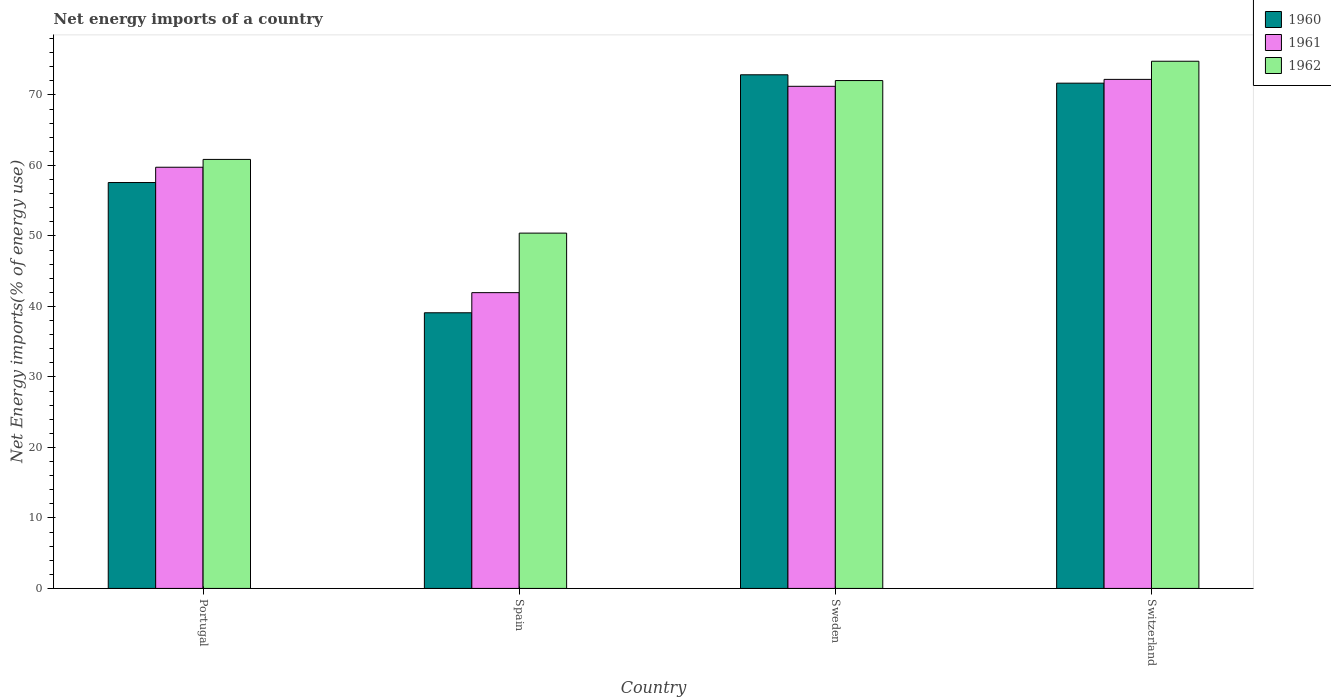Are the number of bars per tick equal to the number of legend labels?
Keep it short and to the point. Yes. Are the number of bars on each tick of the X-axis equal?
Offer a terse response. Yes. What is the net energy imports in 1961 in Spain?
Offer a very short reply. 41.95. Across all countries, what is the maximum net energy imports in 1960?
Your response must be concise. 72.86. Across all countries, what is the minimum net energy imports in 1962?
Provide a succinct answer. 50.4. In which country was the net energy imports in 1961 maximum?
Offer a terse response. Switzerland. In which country was the net energy imports in 1960 minimum?
Your answer should be very brief. Spain. What is the total net energy imports in 1960 in the graph?
Give a very brief answer. 241.2. What is the difference between the net energy imports in 1962 in Spain and that in Switzerland?
Your answer should be very brief. -24.38. What is the difference between the net energy imports in 1962 in Spain and the net energy imports in 1961 in Sweden?
Keep it short and to the point. -20.83. What is the average net energy imports in 1961 per country?
Make the answer very short. 61.28. What is the difference between the net energy imports of/in 1960 and net energy imports of/in 1961 in Sweden?
Make the answer very short. 1.63. What is the ratio of the net energy imports in 1960 in Spain to that in Switzerland?
Keep it short and to the point. 0.55. Is the net energy imports in 1961 in Portugal less than that in Switzerland?
Provide a succinct answer. Yes. What is the difference between the highest and the second highest net energy imports in 1961?
Your answer should be very brief. 12.46. What is the difference between the highest and the lowest net energy imports in 1961?
Your answer should be very brief. 30.25. Are all the bars in the graph horizontal?
Provide a succinct answer. No. How many countries are there in the graph?
Ensure brevity in your answer.  4. What is the difference between two consecutive major ticks on the Y-axis?
Your response must be concise. 10. Are the values on the major ticks of Y-axis written in scientific E-notation?
Your response must be concise. No. Where does the legend appear in the graph?
Make the answer very short. Top right. What is the title of the graph?
Offer a terse response. Net energy imports of a country. Does "1994" appear as one of the legend labels in the graph?
Ensure brevity in your answer.  No. What is the label or title of the Y-axis?
Offer a terse response. Net Energy imports(% of energy use). What is the Net Energy imports(% of energy use) of 1960 in Portugal?
Your answer should be very brief. 57.57. What is the Net Energy imports(% of energy use) of 1961 in Portugal?
Your answer should be compact. 59.74. What is the Net Energy imports(% of energy use) in 1962 in Portugal?
Your answer should be very brief. 60.85. What is the Net Energy imports(% of energy use) in 1960 in Spain?
Make the answer very short. 39.1. What is the Net Energy imports(% of energy use) of 1961 in Spain?
Ensure brevity in your answer.  41.95. What is the Net Energy imports(% of energy use) of 1962 in Spain?
Provide a short and direct response. 50.4. What is the Net Energy imports(% of energy use) of 1960 in Sweden?
Give a very brief answer. 72.86. What is the Net Energy imports(% of energy use) of 1961 in Sweden?
Keep it short and to the point. 71.22. What is the Net Energy imports(% of energy use) in 1962 in Sweden?
Give a very brief answer. 72.04. What is the Net Energy imports(% of energy use) in 1960 in Switzerland?
Your response must be concise. 71.67. What is the Net Energy imports(% of energy use) in 1961 in Switzerland?
Provide a short and direct response. 72.21. What is the Net Energy imports(% of energy use) in 1962 in Switzerland?
Give a very brief answer. 74.78. Across all countries, what is the maximum Net Energy imports(% of energy use) in 1960?
Give a very brief answer. 72.86. Across all countries, what is the maximum Net Energy imports(% of energy use) in 1961?
Make the answer very short. 72.21. Across all countries, what is the maximum Net Energy imports(% of energy use) in 1962?
Your response must be concise. 74.78. Across all countries, what is the minimum Net Energy imports(% of energy use) in 1960?
Your response must be concise. 39.1. Across all countries, what is the minimum Net Energy imports(% of energy use) of 1961?
Ensure brevity in your answer.  41.95. Across all countries, what is the minimum Net Energy imports(% of energy use) in 1962?
Keep it short and to the point. 50.4. What is the total Net Energy imports(% of energy use) of 1960 in the graph?
Keep it short and to the point. 241.2. What is the total Net Energy imports(% of energy use) in 1961 in the graph?
Your response must be concise. 245.13. What is the total Net Energy imports(% of energy use) in 1962 in the graph?
Provide a short and direct response. 258.07. What is the difference between the Net Energy imports(% of energy use) of 1960 in Portugal and that in Spain?
Provide a short and direct response. 18.47. What is the difference between the Net Energy imports(% of energy use) in 1961 in Portugal and that in Spain?
Provide a succinct answer. 17.79. What is the difference between the Net Energy imports(% of energy use) in 1962 in Portugal and that in Spain?
Provide a short and direct response. 10.46. What is the difference between the Net Energy imports(% of energy use) in 1960 in Portugal and that in Sweden?
Provide a succinct answer. -15.28. What is the difference between the Net Energy imports(% of energy use) of 1961 in Portugal and that in Sweden?
Keep it short and to the point. -11.48. What is the difference between the Net Energy imports(% of energy use) in 1962 in Portugal and that in Sweden?
Your answer should be compact. -11.18. What is the difference between the Net Energy imports(% of energy use) in 1960 in Portugal and that in Switzerland?
Provide a succinct answer. -14.09. What is the difference between the Net Energy imports(% of energy use) of 1961 in Portugal and that in Switzerland?
Your answer should be compact. -12.46. What is the difference between the Net Energy imports(% of energy use) in 1962 in Portugal and that in Switzerland?
Your answer should be very brief. -13.93. What is the difference between the Net Energy imports(% of energy use) in 1960 in Spain and that in Sweden?
Offer a very short reply. -33.76. What is the difference between the Net Energy imports(% of energy use) in 1961 in Spain and that in Sweden?
Provide a succinct answer. -29.27. What is the difference between the Net Energy imports(% of energy use) of 1962 in Spain and that in Sweden?
Make the answer very short. -21.64. What is the difference between the Net Energy imports(% of energy use) of 1960 in Spain and that in Switzerland?
Ensure brevity in your answer.  -32.57. What is the difference between the Net Energy imports(% of energy use) in 1961 in Spain and that in Switzerland?
Make the answer very short. -30.25. What is the difference between the Net Energy imports(% of energy use) of 1962 in Spain and that in Switzerland?
Ensure brevity in your answer.  -24.38. What is the difference between the Net Energy imports(% of energy use) of 1960 in Sweden and that in Switzerland?
Your answer should be compact. 1.19. What is the difference between the Net Energy imports(% of energy use) of 1961 in Sweden and that in Switzerland?
Provide a succinct answer. -0.98. What is the difference between the Net Energy imports(% of energy use) of 1962 in Sweden and that in Switzerland?
Make the answer very short. -2.74. What is the difference between the Net Energy imports(% of energy use) of 1960 in Portugal and the Net Energy imports(% of energy use) of 1961 in Spain?
Your answer should be very brief. 15.62. What is the difference between the Net Energy imports(% of energy use) in 1960 in Portugal and the Net Energy imports(% of energy use) in 1962 in Spain?
Your response must be concise. 7.18. What is the difference between the Net Energy imports(% of energy use) in 1961 in Portugal and the Net Energy imports(% of energy use) in 1962 in Spain?
Give a very brief answer. 9.34. What is the difference between the Net Energy imports(% of energy use) in 1960 in Portugal and the Net Energy imports(% of energy use) in 1961 in Sweden?
Provide a short and direct response. -13.65. What is the difference between the Net Energy imports(% of energy use) in 1960 in Portugal and the Net Energy imports(% of energy use) in 1962 in Sweden?
Make the answer very short. -14.46. What is the difference between the Net Energy imports(% of energy use) of 1961 in Portugal and the Net Energy imports(% of energy use) of 1962 in Sweden?
Your response must be concise. -12.3. What is the difference between the Net Energy imports(% of energy use) in 1960 in Portugal and the Net Energy imports(% of energy use) in 1961 in Switzerland?
Your answer should be compact. -14.63. What is the difference between the Net Energy imports(% of energy use) of 1960 in Portugal and the Net Energy imports(% of energy use) of 1962 in Switzerland?
Your answer should be very brief. -17.21. What is the difference between the Net Energy imports(% of energy use) in 1961 in Portugal and the Net Energy imports(% of energy use) in 1962 in Switzerland?
Your answer should be very brief. -15.04. What is the difference between the Net Energy imports(% of energy use) of 1960 in Spain and the Net Energy imports(% of energy use) of 1961 in Sweden?
Your response must be concise. -32.12. What is the difference between the Net Energy imports(% of energy use) in 1960 in Spain and the Net Energy imports(% of energy use) in 1962 in Sweden?
Keep it short and to the point. -32.94. What is the difference between the Net Energy imports(% of energy use) of 1961 in Spain and the Net Energy imports(% of energy use) of 1962 in Sweden?
Make the answer very short. -30.08. What is the difference between the Net Energy imports(% of energy use) in 1960 in Spain and the Net Energy imports(% of energy use) in 1961 in Switzerland?
Your answer should be compact. -33.11. What is the difference between the Net Energy imports(% of energy use) in 1960 in Spain and the Net Energy imports(% of energy use) in 1962 in Switzerland?
Provide a succinct answer. -35.68. What is the difference between the Net Energy imports(% of energy use) in 1961 in Spain and the Net Energy imports(% of energy use) in 1962 in Switzerland?
Your answer should be very brief. -32.82. What is the difference between the Net Energy imports(% of energy use) in 1960 in Sweden and the Net Energy imports(% of energy use) in 1961 in Switzerland?
Your answer should be compact. 0.65. What is the difference between the Net Energy imports(% of energy use) in 1960 in Sweden and the Net Energy imports(% of energy use) in 1962 in Switzerland?
Make the answer very short. -1.92. What is the difference between the Net Energy imports(% of energy use) in 1961 in Sweden and the Net Energy imports(% of energy use) in 1962 in Switzerland?
Offer a very short reply. -3.56. What is the average Net Energy imports(% of energy use) of 1960 per country?
Ensure brevity in your answer.  60.3. What is the average Net Energy imports(% of energy use) of 1961 per country?
Make the answer very short. 61.28. What is the average Net Energy imports(% of energy use) of 1962 per country?
Ensure brevity in your answer.  64.52. What is the difference between the Net Energy imports(% of energy use) of 1960 and Net Energy imports(% of energy use) of 1961 in Portugal?
Your answer should be very brief. -2.17. What is the difference between the Net Energy imports(% of energy use) of 1960 and Net Energy imports(% of energy use) of 1962 in Portugal?
Keep it short and to the point. -3.28. What is the difference between the Net Energy imports(% of energy use) in 1961 and Net Energy imports(% of energy use) in 1962 in Portugal?
Provide a succinct answer. -1.11. What is the difference between the Net Energy imports(% of energy use) of 1960 and Net Energy imports(% of energy use) of 1961 in Spain?
Keep it short and to the point. -2.85. What is the difference between the Net Energy imports(% of energy use) in 1960 and Net Energy imports(% of energy use) in 1962 in Spain?
Your answer should be very brief. -11.3. What is the difference between the Net Energy imports(% of energy use) in 1961 and Net Energy imports(% of energy use) in 1962 in Spain?
Keep it short and to the point. -8.44. What is the difference between the Net Energy imports(% of energy use) of 1960 and Net Energy imports(% of energy use) of 1961 in Sweden?
Provide a succinct answer. 1.63. What is the difference between the Net Energy imports(% of energy use) in 1960 and Net Energy imports(% of energy use) in 1962 in Sweden?
Your answer should be compact. 0.82. What is the difference between the Net Energy imports(% of energy use) of 1961 and Net Energy imports(% of energy use) of 1962 in Sweden?
Provide a short and direct response. -0.81. What is the difference between the Net Energy imports(% of energy use) in 1960 and Net Energy imports(% of energy use) in 1961 in Switzerland?
Your response must be concise. -0.54. What is the difference between the Net Energy imports(% of energy use) in 1960 and Net Energy imports(% of energy use) in 1962 in Switzerland?
Provide a succinct answer. -3.11. What is the difference between the Net Energy imports(% of energy use) of 1961 and Net Energy imports(% of energy use) of 1962 in Switzerland?
Provide a short and direct response. -2.57. What is the ratio of the Net Energy imports(% of energy use) of 1960 in Portugal to that in Spain?
Your answer should be compact. 1.47. What is the ratio of the Net Energy imports(% of energy use) of 1961 in Portugal to that in Spain?
Your answer should be compact. 1.42. What is the ratio of the Net Energy imports(% of energy use) in 1962 in Portugal to that in Spain?
Make the answer very short. 1.21. What is the ratio of the Net Energy imports(% of energy use) of 1960 in Portugal to that in Sweden?
Give a very brief answer. 0.79. What is the ratio of the Net Energy imports(% of energy use) of 1961 in Portugal to that in Sweden?
Your answer should be very brief. 0.84. What is the ratio of the Net Energy imports(% of energy use) of 1962 in Portugal to that in Sweden?
Your answer should be compact. 0.84. What is the ratio of the Net Energy imports(% of energy use) of 1960 in Portugal to that in Switzerland?
Your answer should be very brief. 0.8. What is the ratio of the Net Energy imports(% of energy use) in 1961 in Portugal to that in Switzerland?
Offer a terse response. 0.83. What is the ratio of the Net Energy imports(% of energy use) in 1962 in Portugal to that in Switzerland?
Offer a very short reply. 0.81. What is the ratio of the Net Energy imports(% of energy use) of 1960 in Spain to that in Sweden?
Provide a short and direct response. 0.54. What is the ratio of the Net Energy imports(% of energy use) of 1961 in Spain to that in Sweden?
Provide a succinct answer. 0.59. What is the ratio of the Net Energy imports(% of energy use) in 1962 in Spain to that in Sweden?
Offer a very short reply. 0.7. What is the ratio of the Net Energy imports(% of energy use) in 1960 in Spain to that in Switzerland?
Make the answer very short. 0.55. What is the ratio of the Net Energy imports(% of energy use) of 1961 in Spain to that in Switzerland?
Your answer should be compact. 0.58. What is the ratio of the Net Energy imports(% of energy use) of 1962 in Spain to that in Switzerland?
Offer a very short reply. 0.67. What is the ratio of the Net Energy imports(% of energy use) of 1960 in Sweden to that in Switzerland?
Offer a terse response. 1.02. What is the ratio of the Net Energy imports(% of energy use) of 1961 in Sweden to that in Switzerland?
Make the answer very short. 0.99. What is the ratio of the Net Energy imports(% of energy use) in 1962 in Sweden to that in Switzerland?
Make the answer very short. 0.96. What is the difference between the highest and the second highest Net Energy imports(% of energy use) in 1960?
Offer a terse response. 1.19. What is the difference between the highest and the second highest Net Energy imports(% of energy use) of 1961?
Your answer should be very brief. 0.98. What is the difference between the highest and the second highest Net Energy imports(% of energy use) in 1962?
Your answer should be compact. 2.74. What is the difference between the highest and the lowest Net Energy imports(% of energy use) of 1960?
Your response must be concise. 33.76. What is the difference between the highest and the lowest Net Energy imports(% of energy use) in 1961?
Your answer should be very brief. 30.25. What is the difference between the highest and the lowest Net Energy imports(% of energy use) in 1962?
Offer a very short reply. 24.38. 